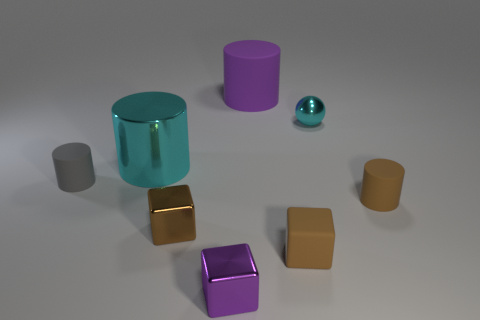What number of small objects are cylinders or matte blocks? Upon inspecting the image, there are a total of three objects that can be classified as either cylinders or matte blocks. Two of these objects are cylindrical - one is transparent teal and the other is opaque gray. The third object is a matte block with a gold finish. 